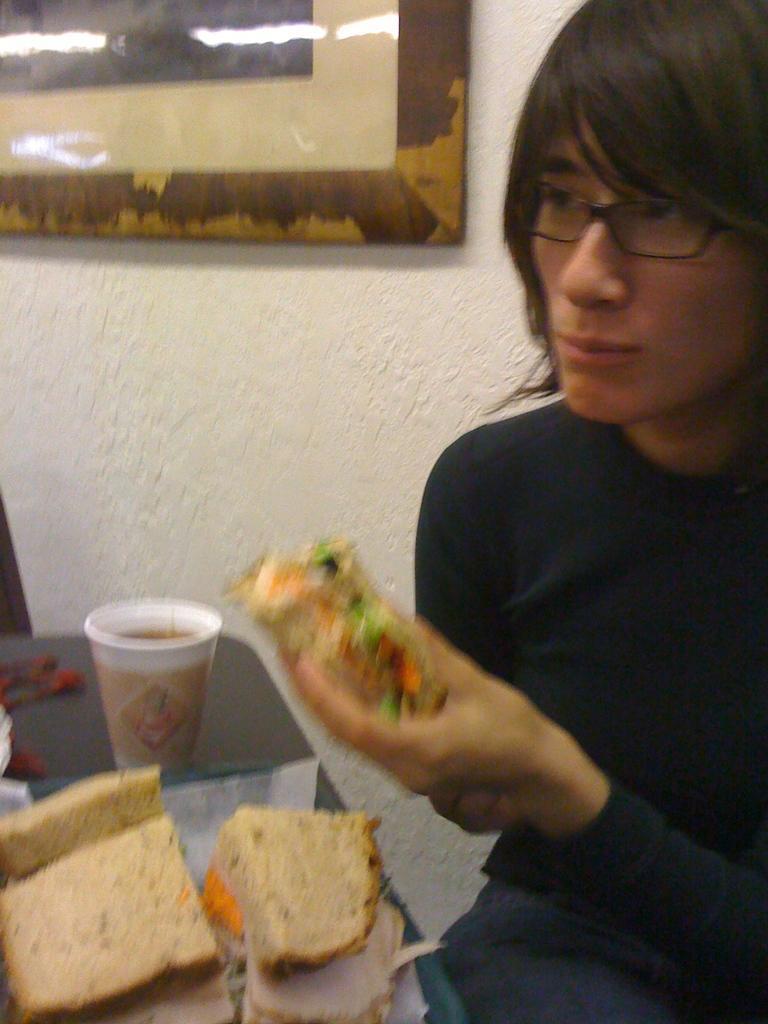How would you summarize this image in a sentence or two? In this image I can see a person wearing black color dress and holding a food which is in brown and green color, in front I can see a glass and food on the table. Background I can see a frame attached to the wall and the wall is in white color. 